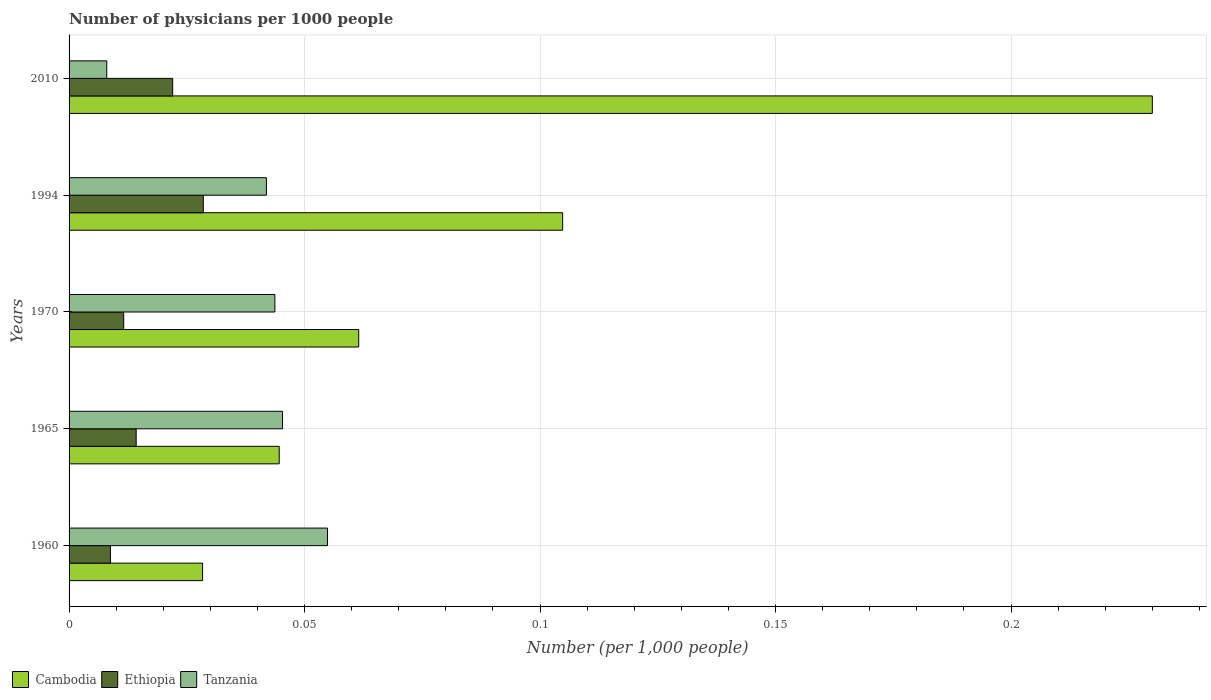Are the number of bars per tick equal to the number of legend labels?
Keep it short and to the point. Yes. Are the number of bars on each tick of the Y-axis equal?
Offer a terse response. Yes. What is the number of physicians in Tanzania in 2010?
Offer a very short reply. 0.01. Across all years, what is the maximum number of physicians in Ethiopia?
Give a very brief answer. 0.03. Across all years, what is the minimum number of physicians in Cambodia?
Keep it short and to the point. 0.03. In which year was the number of physicians in Tanzania maximum?
Give a very brief answer. 1960. What is the total number of physicians in Tanzania in the graph?
Keep it short and to the point. 0.19. What is the difference between the number of physicians in Tanzania in 1994 and that in 2010?
Give a very brief answer. 0.03. What is the difference between the number of physicians in Tanzania in 2010 and the number of physicians in Cambodia in 1965?
Provide a short and direct response. -0.04. What is the average number of physicians in Tanzania per year?
Offer a very short reply. 0.04. In the year 1970, what is the difference between the number of physicians in Cambodia and number of physicians in Tanzania?
Your response must be concise. 0.02. In how many years, is the number of physicians in Tanzania greater than 0.05 ?
Keep it short and to the point. 1. What is the ratio of the number of physicians in Cambodia in 1965 to that in 2010?
Keep it short and to the point. 0.19. What is the difference between the highest and the second highest number of physicians in Tanzania?
Offer a terse response. 0.01. What is the difference between the highest and the lowest number of physicians in Ethiopia?
Make the answer very short. 0.02. What does the 2nd bar from the top in 1970 represents?
Your answer should be very brief. Ethiopia. What does the 3rd bar from the bottom in 2010 represents?
Ensure brevity in your answer.  Tanzania. How many years are there in the graph?
Provide a succinct answer. 5. What is the difference between two consecutive major ticks on the X-axis?
Offer a terse response. 0.05. Are the values on the major ticks of X-axis written in scientific E-notation?
Your answer should be very brief. No. Does the graph contain any zero values?
Ensure brevity in your answer.  No. Where does the legend appear in the graph?
Keep it short and to the point. Bottom left. How many legend labels are there?
Provide a succinct answer. 3. What is the title of the graph?
Provide a short and direct response. Number of physicians per 1000 people. Does "Czech Republic" appear as one of the legend labels in the graph?
Provide a succinct answer. No. What is the label or title of the X-axis?
Provide a succinct answer. Number (per 1,0 people). What is the label or title of the Y-axis?
Provide a short and direct response. Years. What is the Number (per 1,000 people) in Cambodia in 1960?
Provide a short and direct response. 0.03. What is the Number (per 1,000 people) of Ethiopia in 1960?
Keep it short and to the point. 0.01. What is the Number (per 1,000 people) of Tanzania in 1960?
Your answer should be very brief. 0.05. What is the Number (per 1,000 people) of Cambodia in 1965?
Your answer should be compact. 0.04. What is the Number (per 1,000 people) in Ethiopia in 1965?
Your answer should be very brief. 0.01. What is the Number (per 1,000 people) in Tanzania in 1965?
Offer a terse response. 0.05. What is the Number (per 1,000 people) in Cambodia in 1970?
Your response must be concise. 0.06. What is the Number (per 1,000 people) of Ethiopia in 1970?
Offer a very short reply. 0.01. What is the Number (per 1,000 people) in Tanzania in 1970?
Make the answer very short. 0.04. What is the Number (per 1,000 people) of Cambodia in 1994?
Provide a short and direct response. 0.1. What is the Number (per 1,000 people) of Ethiopia in 1994?
Provide a short and direct response. 0.03. What is the Number (per 1,000 people) in Tanzania in 1994?
Keep it short and to the point. 0.04. What is the Number (per 1,000 people) of Cambodia in 2010?
Ensure brevity in your answer.  0.23. What is the Number (per 1,000 people) in Ethiopia in 2010?
Offer a terse response. 0.02. What is the Number (per 1,000 people) in Tanzania in 2010?
Ensure brevity in your answer.  0.01. Across all years, what is the maximum Number (per 1,000 people) in Cambodia?
Offer a very short reply. 0.23. Across all years, what is the maximum Number (per 1,000 people) of Ethiopia?
Offer a very short reply. 0.03. Across all years, what is the maximum Number (per 1,000 people) in Tanzania?
Your response must be concise. 0.05. Across all years, what is the minimum Number (per 1,000 people) of Cambodia?
Make the answer very short. 0.03. Across all years, what is the minimum Number (per 1,000 people) of Ethiopia?
Offer a terse response. 0.01. Across all years, what is the minimum Number (per 1,000 people) of Tanzania?
Provide a succinct answer. 0.01. What is the total Number (per 1,000 people) of Cambodia in the graph?
Offer a very short reply. 0.47. What is the total Number (per 1,000 people) of Ethiopia in the graph?
Your response must be concise. 0.09. What is the total Number (per 1,000 people) of Tanzania in the graph?
Offer a terse response. 0.19. What is the difference between the Number (per 1,000 people) in Cambodia in 1960 and that in 1965?
Ensure brevity in your answer.  -0.02. What is the difference between the Number (per 1,000 people) of Ethiopia in 1960 and that in 1965?
Provide a succinct answer. -0.01. What is the difference between the Number (per 1,000 people) in Tanzania in 1960 and that in 1965?
Ensure brevity in your answer.  0.01. What is the difference between the Number (per 1,000 people) of Cambodia in 1960 and that in 1970?
Make the answer very short. -0.03. What is the difference between the Number (per 1,000 people) in Ethiopia in 1960 and that in 1970?
Your answer should be compact. -0. What is the difference between the Number (per 1,000 people) in Tanzania in 1960 and that in 1970?
Provide a short and direct response. 0.01. What is the difference between the Number (per 1,000 people) in Cambodia in 1960 and that in 1994?
Your answer should be very brief. -0.08. What is the difference between the Number (per 1,000 people) of Ethiopia in 1960 and that in 1994?
Provide a succinct answer. -0.02. What is the difference between the Number (per 1,000 people) in Tanzania in 1960 and that in 1994?
Your answer should be compact. 0.01. What is the difference between the Number (per 1,000 people) in Cambodia in 1960 and that in 2010?
Give a very brief answer. -0.2. What is the difference between the Number (per 1,000 people) of Ethiopia in 1960 and that in 2010?
Offer a terse response. -0.01. What is the difference between the Number (per 1,000 people) in Tanzania in 1960 and that in 2010?
Make the answer very short. 0.05. What is the difference between the Number (per 1,000 people) in Cambodia in 1965 and that in 1970?
Your response must be concise. -0.02. What is the difference between the Number (per 1,000 people) of Ethiopia in 1965 and that in 1970?
Your answer should be very brief. 0. What is the difference between the Number (per 1,000 people) of Tanzania in 1965 and that in 1970?
Keep it short and to the point. 0. What is the difference between the Number (per 1,000 people) of Cambodia in 1965 and that in 1994?
Keep it short and to the point. -0.06. What is the difference between the Number (per 1,000 people) in Ethiopia in 1965 and that in 1994?
Provide a succinct answer. -0.01. What is the difference between the Number (per 1,000 people) of Tanzania in 1965 and that in 1994?
Offer a very short reply. 0. What is the difference between the Number (per 1,000 people) in Cambodia in 1965 and that in 2010?
Offer a very short reply. -0.19. What is the difference between the Number (per 1,000 people) of Ethiopia in 1965 and that in 2010?
Make the answer very short. -0.01. What is the difference between the Number (per 1,000 people) in Tanzania in 1965 and that in 2010?
Your answer should be compact. 0.04. What is the difference between the Number (per 1,000 people) of Cambodia in 1970 and that in 1994?
Ensure brevity in your answer.  -0.04. What is the difference between the Number (per 1,000 people) in Ethiopia in 1970 and that in 1994?
Give a very brief answer. -0.02. What is the difference between the Number (per 1,000 people) of Tanzania in 1970 and that in 1994?
Offer a very short reply. 0. What is the difference between the Number (per 1,000 people) in Cambodia in 1970 and that in 2010?
Your response must be concise. -0.17. What is the difference between the Number (per 1,000 people) of Ethiopia in 1970 and that in 2010?
Offer a very short reply. -0.01. What is the difference between the Number (per 1,000 people) of Tanzania in 1970 and that in 2010?
Make the answer very short. 0.04. What is the difference between the Number (per 1,000 people) in Cambodia in 1994 and that in 2010?
Provide a succinct answer. -0.13. What is the difference between the Number (per 1,000 people) of Ethiopia in 1994 and that in 2010?
Your response must be concise. 0.01. What is the difference between the Number (per 1,000 people) in Tanzania in 1994 and that in 2010?
Keep it short and to the point. 0.03. What is the difference between the Number (per 1,000 people) in Cambodia in 1960 and the Number (per 1,000 people) in Ethiopia in 1965?
Offer a very short reply. 0.01. What is the difference between the Number (per 1,000 people) in Cambodia in 1960 and the Number (per 1,000 people) in Tanzania in 1965?
Offer a terse response. -0.02. What is the difference between the Number (per 1,000 people) in Ethiopia in 1960 and the Number (per 1,000 people) in Tanzania in 1965?
Your answer should be very brief. -0.04. What is the difference between the Number (per 1,000 people) of Cambodia in 1960 and the Number (per 1,000 people) of Ethiopia in 1970?
Keep it short and to the point. 0.02. What is the difference between the Number (per 1,000 people) in Cambodia in 1960 and the Number (per 1,000 people) in Tanzania in 1970?
Provide a succinct answer. -0.02. What is the difference between the Number (per 1,000 people) of Ethiopia in 1960 and the Number (per 1,000 people) of Tanzania in 1970?
Provide a short and direct response. -0.03. What is the difference between the Number (per 1,000 people) in Cambodia in 1960 and the Number (per 1,000 people) in Ethiopia in 1994?
Give a very brief answer. -0. What is the difference between the Number (per 1,000 people) of Cambodia in 1960 and the Number (per 1,000 people) of Tanzania in 1994?
Your answer should be very brief. -0.01. What is the difference between the Number (per 1,000 people) of Ethiopia in 1960 and the Number (per 1,000 people) of Tanzania in 1994?
Your response must be concise. -0.03. What is the difference between the Number (per 1,000 people) in Cambodia in 1960 and the Number (per 1,000 people) in Ethiopia in 2010?
Ensure brevity in your answer.  0.01. What is the difference between the Number (per 1,000 people) in Cambodia in 1960 and the Number (per 1,000 people) in Tanzania in 2010?
Your response must be concise. 0.02. What is the difference between the Number (per 1,000 people) of Ethiopia in 1960 and the Number (per 1,000 people) of Tanzania in 2010?
Provide a succinct answer. 0. What is the difference between the Number (per 1,000 people) in Cambodia in 1965 and the Number (per 1,000 people) in Ethiopia in 1970?
Make the answer very short. 0.03. What is the difference between the Number (per 1,000 people) of Cambodia in 1965 and the Number (per 1,000 people) of Tanzania in 1970?
Provide a short and direct response. 0. What is the difference between the Number (per 1,000 people) in Ethiopia in 1965 and the Number (per 1,000 people) in Tanzania in 1970?
Provide a short and direct response. -0.03. What is the difference between the Number (per 1,000 people) in Cambodia in 1965 and the Number (per 1,000 people) in Ethiopia in 1994?
Provide a short and direct response. 0.02. What is the difference between the Number (per 1,000 people) in Cambodia in 1965 and the Number (per 1,000 people) in Tanzania in 1994?
Give a very brief answer. 0. What is the difference between the Number (per 1,000 people) in Ethiopia in 1965 and the Number (per 1,000 people) in Tanzania in 1994?
Provide a short and direct response. -0.03. What is the difference between the Number (per 1,000 people) of Cambodia in 1965 and the Number (per 1,000 people) of Ethiopia in 2010?
Ensure brevity in your answer.  0.02. What is the difference between the Number (per 1,000 people) of Cambodia in 1965 and the Number (per 1,000 people) of Tanzania in 2010?
Provide a short and direct response. 0.04. What is the difference between the Number (per 1,000 people) in Ethiopia in 1965 and the Number (per 1,000 people) in Tanzania in 2010?
Offer a terse response. 0.01. What is the difference between the Number (per 1,000 people) in Cambodia in 1970 and the Number (per 1,000 people) in Ethiopia in 1994?
Keep it short and to the point. 0.03. What is the difference between the Number (per 1,000 people) of Cambodia in 1970 and the Number (per 1,000 people) of Tanzania in 1994?
Make the answer very short. 0.02. What is the difference between the Number (per 1,000 people) in Ethiopia in 1970 and the Number (per 1,000 people) in Tanzania in 1994?
Offer a very short reply. -0.03. What is the difference between the Number (per 1,000 people) in Cambodia in 1970 and the Number (per 1,000 people) in Ethiopia in 2010?
Provide a succinct answer. 0.04. What is the difference between the Number (per 1,000 people) in Cambodia in 1970 and the Number (per 1,000 people) in Tanzania in 2010?
Provide a succinct answer. 0.05. What is the difference between the Number (per 1,000 people) of Ethiopia in 1970 and the Number (per 1,000 people) of Tanzania in 2010?
Your answer should be very brief. 0. What is the difference between the Number (per 1,000 people) in Cambodia in 1994 and the Number (per 1,000 people) in Ethiopia in 2010?
Offer a terse response. 0.08. What is the difference between the Number (per 1,000 people) in Cambodia in 1994 and the Number (per 1,000 people) in Tanzania in 2010?
Keep it short and to the point. 0.1. What is the difference between the Number (per 1,000 people) in Ethiopia in 1994 and the Number (per 1,000 people) in Tanzania in 2010?
Provide a succinct answer. 0.02. What is the average Number (per 1,000 people) of Cambodia per year?
Offer a terse response. 0.09. What is the average Number (per 1,000 people) of Ethiopia per year?
Your response must be concise. 0.02. What is the average Number (per 1,000 people) in Tanzania per year?
Make the answer very short. 0.04. In the year 1960, what is the difference between the Number (per 1,000 people) in Cambodia and Number (per 1,000 people) in Ethiopia?
Provide a succinct answer. 0.02. In the year 1960, what is the difference between the Number (per 1,000 people) of Cambodia and Number (per 1,000 people) of Tanzania?
Offer a terse response. -0.03. In the year 1960, what is the difference between the Number (per 1,000 people) in Ethiopia and Number (per 1,000 people) in Tanzania?
Make the answer very short. -0.05. In the year 1965, what is the difference between the Number (per 1,000 people) of Cambodia and Number (per 1,000 people) of Ethiopia?
Provide a short and direct response. 0.03. In the year 1965, what is the difference between the Number (per 1,000 people) in Cambodia and Number (per 1,000 people) in Tanzania?
Your answer should be very brief. -0. In the year 1965, what is the difference between the Number (per 1,000 people) of Ethiopia and Number (per 1,000 people) of Tanzania?
Offer a very short reply. -0.03. In the year 1970, what is the difference between the Number (per 1,000 people) in Cambodia and Number (per 1,000 people) in Ethiopia?
Your answer should be very brief. 0.05. In the year 1970, what is the difference between the Number (per 1,000 people) of Cambodia and Number (per 1,000 people) of Tanzania?
Provide a succinct answer. 0.02. In the year 1970, what is the difference between the Number (per 1,000 people) of Ethiopia and Number (per 1,000 people) of Tanzania?
Offer a very short reply. -0.03. In the year 1994, what is the difference between the Number (per 1,000 people) of Cambodia and Number (per 1,000 people) of Ethiopia?
Keep it short and to the point. 0.08. In the year 1994, what is the difference between the Number (per 1,000 people) of Cambodia and Number (per 1,000 people) of Tanzania?
Offer a very short reply. 0.06. In the year 1994, what is the difference between the Number (per 1,000 people) in Ethiopia and Number (per 1,000 people) in Tanzania?
Make the answer very short. -0.01. In the year 2010, what is the difference between the Number (per 1,000 people) in Cambodia and Number (per 1,000 people) in Ethiopia?
Provide a short and direct response. 0.21. In the year 2010, what is the difference between the Number (per 1,000 people) of Cambodia and Number (per 1,000 people) of Tanzania?
Your answer should be compact. 0.22. In the year 2010, what is the difference between the Number (per 1,000 people) in Ethiopia and Number (per 1,000 people) in Tanzania?
Your answer should be compact. 0.01. What is the ratio of the Number (per 1,000 people) in Cambodia in 1960 to that in 1965?
Provide a succinct answer. 0.64. What is the ratio of the Number (per 1,000 people) in Ethiopia in 1960 to that in 1965?
Provide a succinct answer. 0.62. What is the ratio of the Number (per 1,000 people) of Tanzania in 1960 to that in 1965?
Your answer should be compact. 1.21. What is the ratio of the Number (per 1,000 people) in Cambodia in 1960 to that in 1970?
Your response must be concise. 0.46. What is the ratio of the Number (per 1,000 people) of Ethiopia in 1960 to that in 1970?
Offer a terse response. 0.76. What is the ratio of the Number (per 1,000 people) in Tanzania in 1960 to that in 1970?
Keep it short and to the point. 1.26. What is the ratio of the Number (per 1,000 people) in Cambodia in 1960 to that in 1994?
Offer a very short reply. 0.27. What is the ratio of the Number (per 1,000 people) of Ethiopia in 1960 to that in 1994?
Provide a short and direct response. 0.31. What is the ratio of the Number (per 1,000 people) in Tanzania in 1960 to that in 1994?
Ensure brevity in your answer.  1.31. What is the ratio of the Number (per 1,000 people) in Cambodia in 1960 to that in 2010?
Offer a very short reply. 0.12. What is the ratio of the Number (per 1,000 people) in Ethiopia in 1960 to that in 2010?
Provide a short and direct response. 0.4. What is the ratio of the Number (per 1,000 people) of Tanzania in 1960 to that in 2010?
Offer a terse response. 6.86. What is the ratio of the Number (per 1,000 people) of Cambodia in 1965 to that in 1970?
Provide a short and direct response. 0.73. What is the ratio of the Number (per 1,000 people) in Ethiopia in 1965 to that in 1970?
Provide a short and direct response. 1.23. What is the ratio of the Number (per 1,000 people) in Tanzania in 1965 to that in 1970?
Provide a succinct answer. 1.04. What is the ratio of the Number (per 1,000 people) of Cambodia in 1965 to that in 1994?
Your answer should be compact. 0.43. What is the ratio of the Number (per 1,000 people) in Ethiopia in 1965 to that in 1994?
Ensure brevity in your answer.  0.5. What is the ratio of the Number (per 1,000 people) in Tanzania in 1965 to that in 1994?
Your answer should be very brief. 1.08. What is the ratio of the Number (per 1,000 people) of Cambodia in 1965 to that in 2010?
Your answer should be very brief. 0.19. What is the ratio of the Number (per 1,000 people) in Ethiopia in 1965 to that in 2010?
Make the answer very short. 0.65. What is the ratio of the Number (per 1,000 people) of Tanzania in 1965 to that in 2010?
Provide a short and direct response. 5.67. What is the ratio of the Number (per 1,000 people) of Cambodia in 1970 to that in 1994?
Keep it short and to the point. 0.59. What is the ratio of the Number (per 1,000 people) of Ethiopia in 1970 to that in 1994?
Your response must be concise. 0.41. What is the ratio of the Number (per 1,000 people) in Tanzania in 1970 to that in 1994?
Offer a very short reply. 1.04. What is the ratio of the Number (per 1,000 people) of Cambodia in 1970 to that in 2010?
Your response must be concise. 0.27. What is the ratio of the Number (per 1,000 people) of Ethiopia in 1970 to that in 2010?
Give a very brief answer. 0.53. What is the ratio of the Number (per 1,000 people) in Tanzania in 1970 to that in 2010?
Your answer should be compact. 5.46. What is the ratio of the Number (per 1,000 people) of Cambodia in 1994 to that in 2010?
Keep it short and to the point. 0.46. What is the ratio of the Number (per 1,000 people) in Ethiopia in 1994 to that in 2010?
Provide a short and direct response. 1.3. What is the ratio of the Number (per 1,000 people) in Tanzania in 1994 to that in 2010?
Your answer should be very brief. 5.24. What is the difference between the highest and the second highest Number (per 1,000 people) in Cambodia?
Keep it short and to the point. 0.13. What is the difference between the highest and the second highest Number (per 1,000 people) of Ethiopia?
Your response must be concise. 0.01. What is the difference between the highest and the second highest Number (per 1,000 people) of Tanzania?
Your answer should be very brief. 0.01. What is the difference between the highest and the lowest Number (per 1,000 people) in Cambodia?
Make the answer very short. 0.2. What is the difference between the highest and the lowest Number (per 1,000 people) of Ethiopia?
Make the answer very short. 0.02. What is the difference between the highest and the lowest Number (per 1,000 people) in Tanzania?
Give a very brief answer. 0.05. 